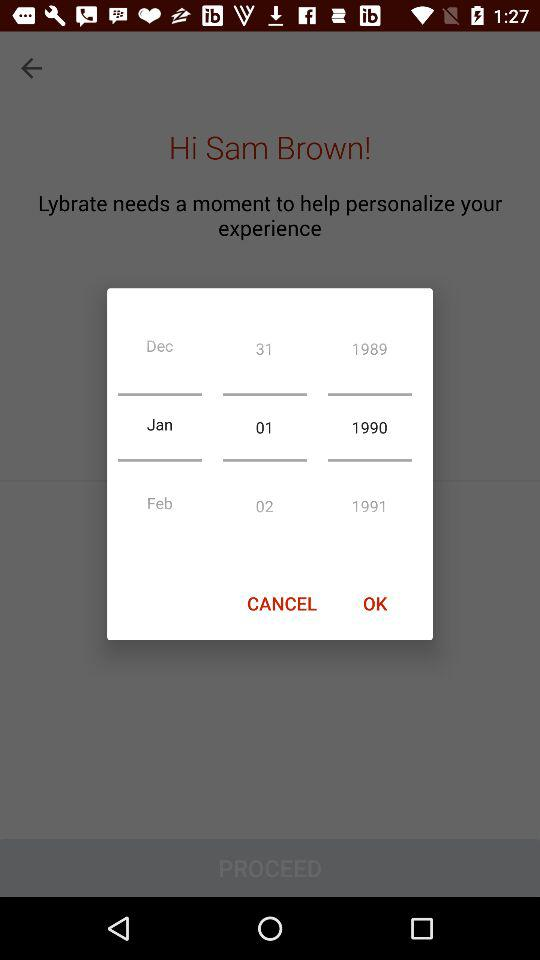How many years are shown on this screen?
Answer the question using a single word or phrase. 3 